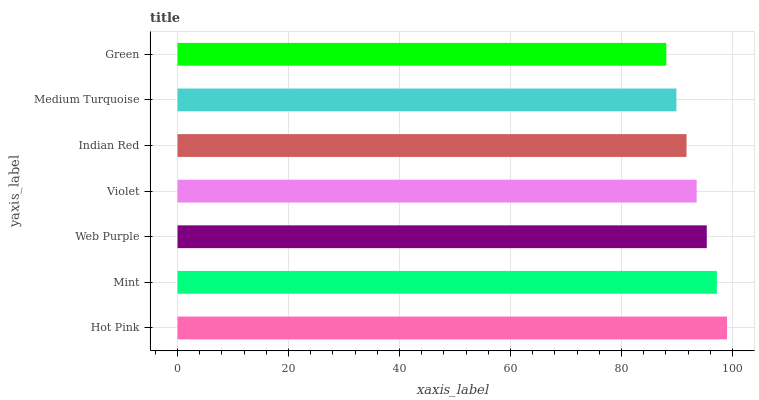Is Green the minimum?
Answer yes or no. Yes. Is Hot Pink the maximum?
Answer yes or no. Yes. Is Mint the minimum?
Answer yes or no. No. Is Mint the maximum?
Answer yes or no. No. Is Hot Pink greater than Mint?
Answer yes or no. Yes. Is Mint less than Hot Pink?
Answer yes or no. Yes. Is Mint greater than Hot Pink?
Answer yes or no. No. Is Hot Pink less than Mint?
Answer yes or no. No. Is Violet the high median?
Answer yes or no. Yes. Is Violet the low median?
Answer yes or no. Yes. Is Web Purple the high median?
Answer yes or no. No. Is Hot Pink the low median?
Answer yes or no. No. 